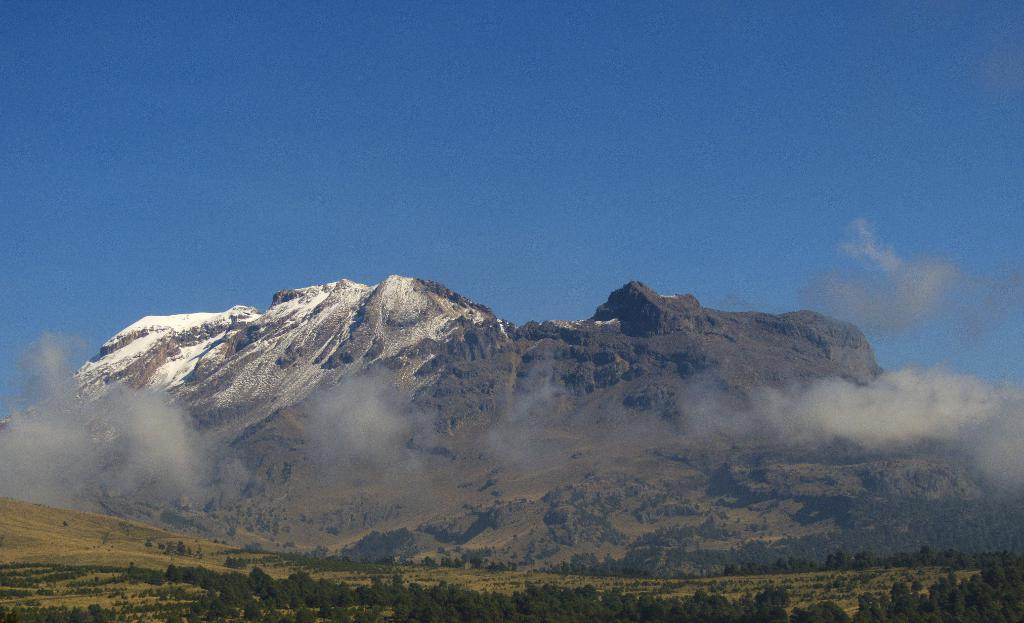What type of natural features can be seen in the image? There are trees and mountains in the image. What else is visible in the sky in the image? There are clouds in the image. Can you see a cough in the image? There is no cough present in the image, as a cough is not a visual object. 